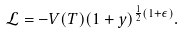<formula> <loc_0><loc_0><loc_500><loc_500>\mathcal { L } = - V ( T ) ( 1 + y ) ^ { \frac { 1 } { 2 } ( 1 + \epsilon ) } .</formula> 